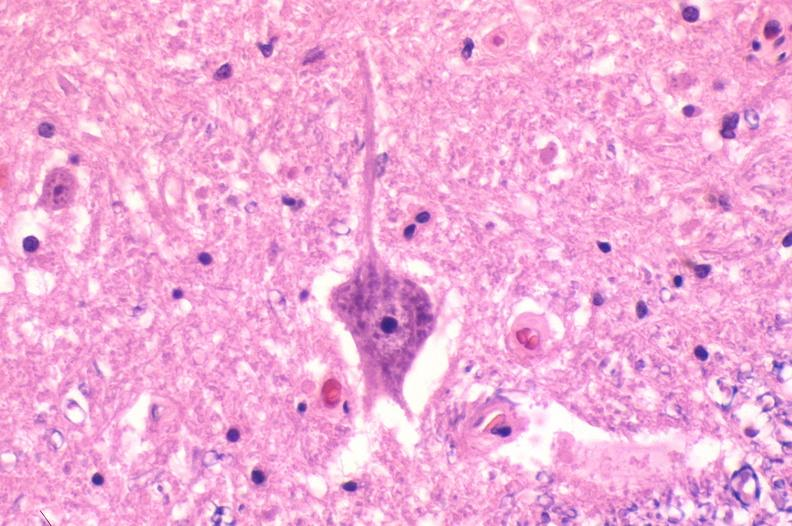s nervous present?
Answer the question using a single word or phrase. Yes 